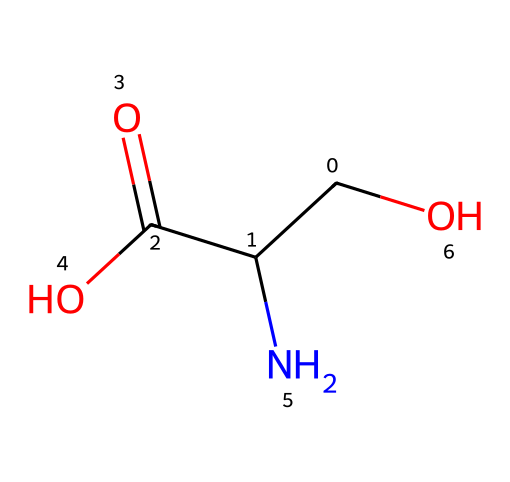What is the functional group present in this chemical? The chemical contains a carboxylic acid group (-COOH), which is evident from the presence of the carbon atom double-bonded to an oxygen atom and single-bonded to a hydroxyl group (-OH).
Answer: carboxylic acid How many carbon atoms are in the chemical structure? By examining the SMILES representation, there are three carbon atoms present: one in the carboxylic acid group and two bonded in the main chain.
Answer: 3 What type of amino acid does this chemical resemble? The presence of the amino group (-NH2) and a hydroxyl group with a carboxylic acid indicates this structure closely resembles serine, which is a common amino acid that has these groups.
Answer: serine What is the stereochemistry of this molecule? The configuration shows that there is at least one chiral center due to the carbon attached to four different groups; thus, stereochemistry involves consideration of R/S configuration.
Answer: chiral What is the total number of hydrogen atoms in the molecule? For each carbon and nitrogen in the structure, the total hydrogens can be calculated: one carbon in carboxylic has one hydrogen, two in the main chain contribute more, and there’s one on nitrogen for a total of seven hydrogens in the entire structure including those in functional groups.
Answer: 7 What is the overall charge of this molecule at physiological pH? The carboxylic acid and amino groups likely interact such that, at physiological pH, the carboxylic acid would be deprotonated (negative), and the amino group remains protonated (positive), resulting in a neutral overall charge.
Answer: neutral 